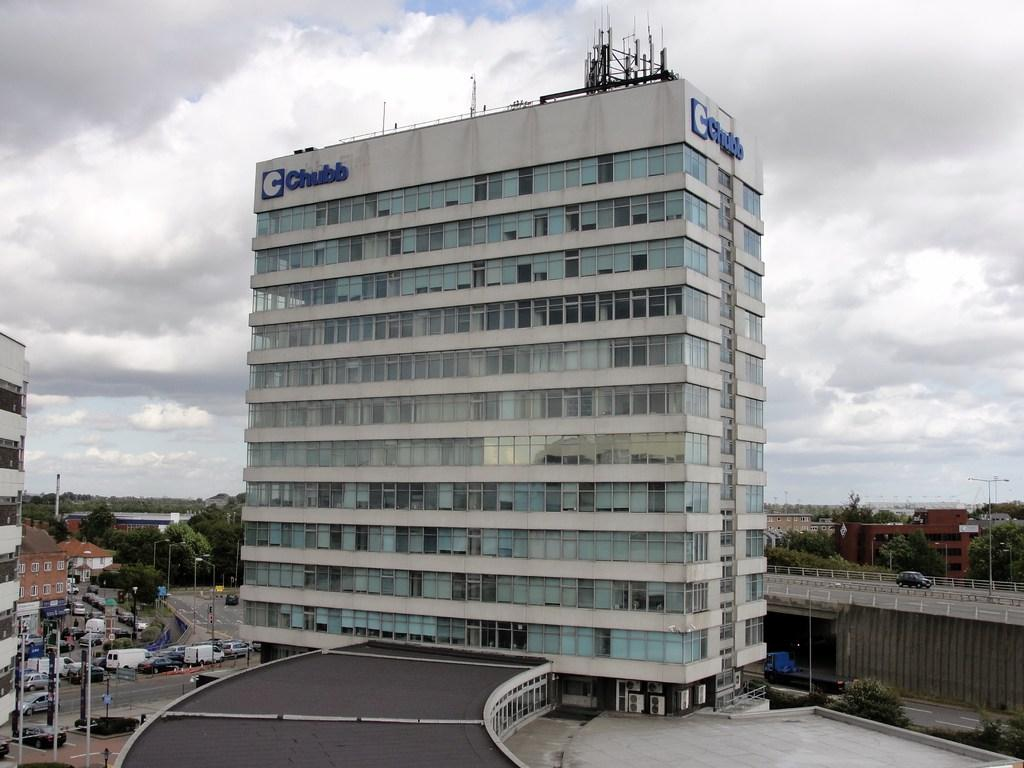What type of structures can be seen in the image? There are buildings in the image. What else is present on the ground in the image? There are vehicles on the road in the image. What can be seen in the background of the image? The sky is visible in the background of the image. How many twigs are being used to construct the buildings in the image? There are no twigs present in the image; the buildings are constructed with other materials. What type of bean is growing on the side of the road in the image? There are no beans present in the image; the focus is on the buildings and vehicles. 